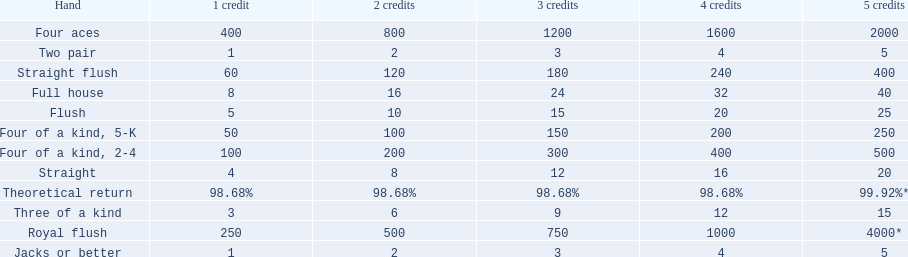What is the values in the 5 credits area? 4000*, 400, 2000, 500, 250, 40, 25, 20, 15, 5, 5. Which of these is for a four of a kind? 500, 250. What is the higher value? 500. What hand is this for Four of a kind, 2-4. 